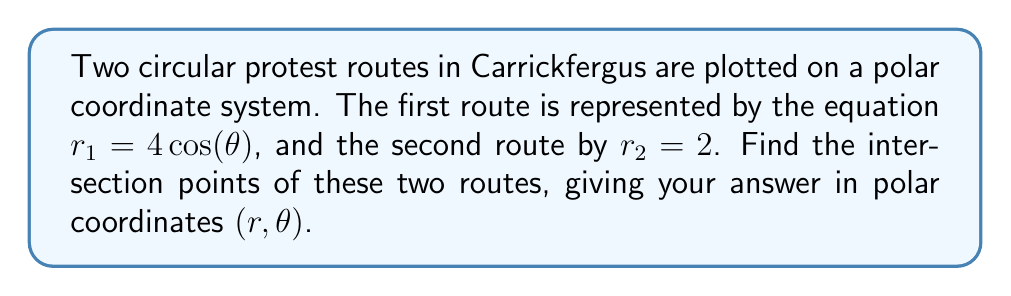Teach me how to tackle this problem. To find the intersection points, we need to solve the system of equations:

$$r_1 = r_2$$
$$4\cos(\theta) = 2$$

Step 1: Solve for $\theta$
$$\cos(\theta) = \frac{1}{2}$$

This equation has two solutions in the interval $[0, 2\pi)$:
$$\theta_1 = \frac{\pi}{3} \text{ and } \theta_2 = \frac{5\pi}{3}$$

Step 2: Find the corresponding $r$ values
For both solutions, $r = 2$ (since this is the equation of the second circle).

Step 3: Express the solutions in polar coordinates $(r,\theta)$

[asy]
import geometry;

size(200);
draw(circle((0,0),2));
draw((-4,0)--(4,0),blue);
draw((0,-2)--(0,2),blue);

pair z1 = 2*dir(60);
pair z2 = 2*dir(300);

dot(z1,red);
dot(z2,red);

label("$(2,\frac{\pi}{3})$", z1, NE);
label("$(2,\frac{5\pi}{3})$", z2, SE);
[/asy]

The intersection points are $(2,\frac{\pi}{3})$ and $(2,\frac{5\pi}{3})$.
Answer: The intersection points are $(2,\frac{\pi}{3})$ and $(2,\frac{5\pi}{3})$. 